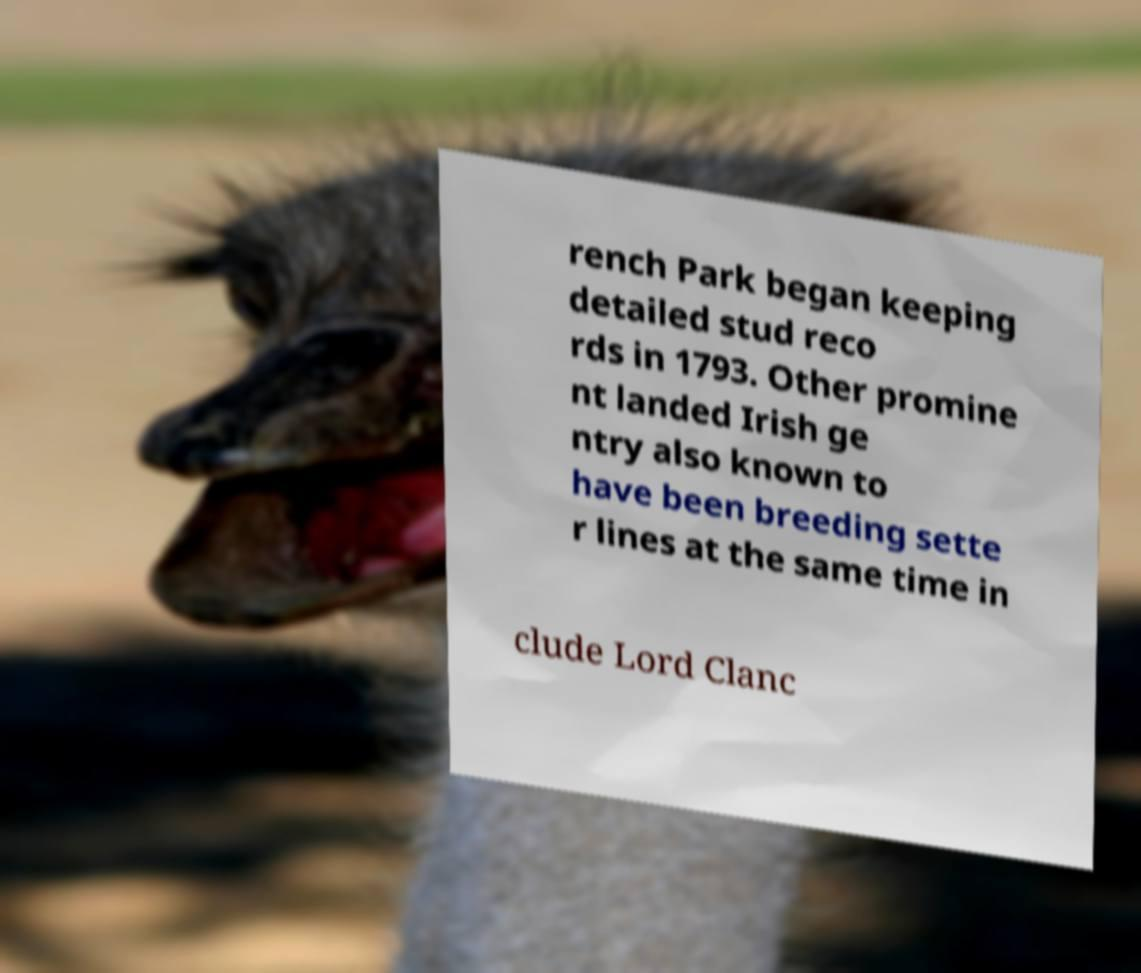I need the written content from this picture converted into text. Can you do that? rench Park began keeping detailed stud reco rds in 1793. Other promine nt landed Irish ge ntry also known to have been breeding sette r lines at the same time in clude Lord Clanc 